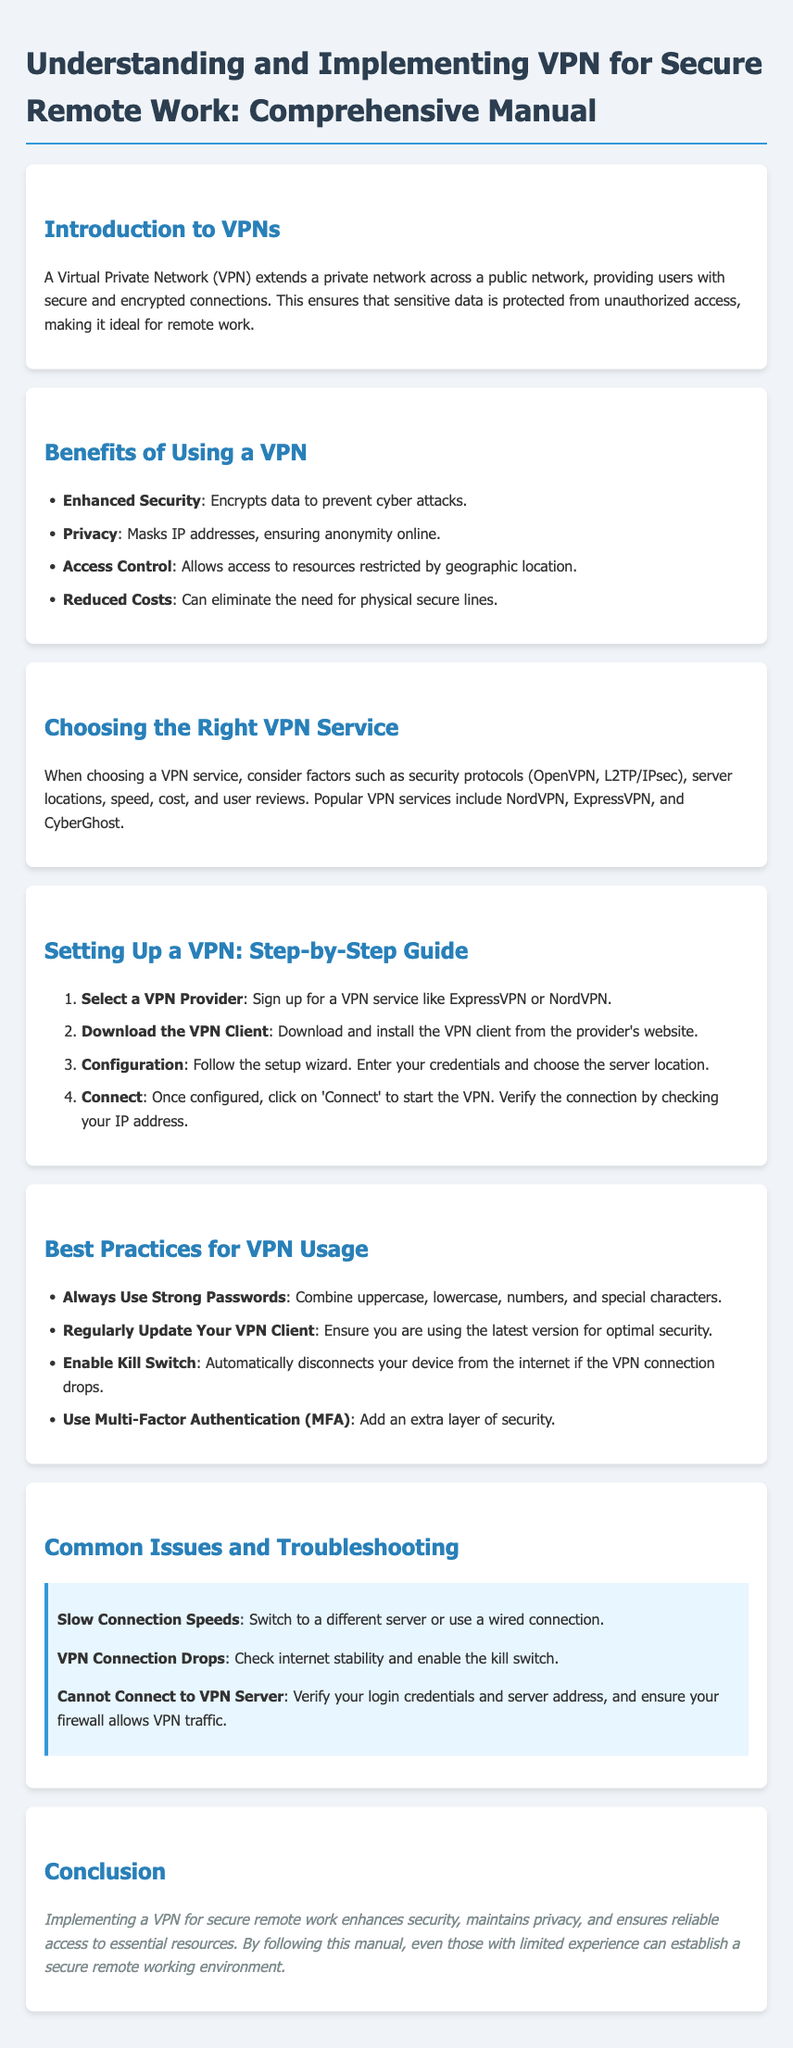What is a VPN? A VPN is defined in the document as a Virtual Private Network that extends a private network across a public network, providing secure and encrypted connections.
Answer: Virtual Private Network What are two benefits of using a VPN? The document lists several benefits; two of them include enhanced security and privacy.
Answer: Enhanced Security, Privacy Which VPN services are mentioned as popular? The document names NordVPN, ExpressVPN, and CyberGhost as popular VPN services.
Answer: NordVPN, ExpressVPN, CyberGhost What should you do first when setting up a VPN? The first step in the setup guide states to select a VPN provider by signing up for a VPN service.
Answer: Select a VPN Provider What is the highlighted issue related to slow connection speeds? The troubleshooting section mentions switching to a different server or using a wired connection when experiencing slow connection speeds.
Answer: Switch to a different server or use a wired connection How many steps are there in the VPN setup guide? The document outlines four steps in the VPN setup guide.
Answer: Four steps What security measure is recommended to add an extra layer of protection? The document recommends enabling Multi-Factor Authentication (MFA) as an additional security measure.
Answer: Multi-Factor Authentication (MFA) What is a kill switch? The document describes a kill switch as a feature that automatically disconnects your device from the internet if the VPN connection drops.
Answer: Automatically disconnects your device from the internet if the VPN connection drops What type of document is this? The document is a user guide that aims to provide comprehensive information about understanding and implementing VPN for secure remote work.
Answer: User guide 